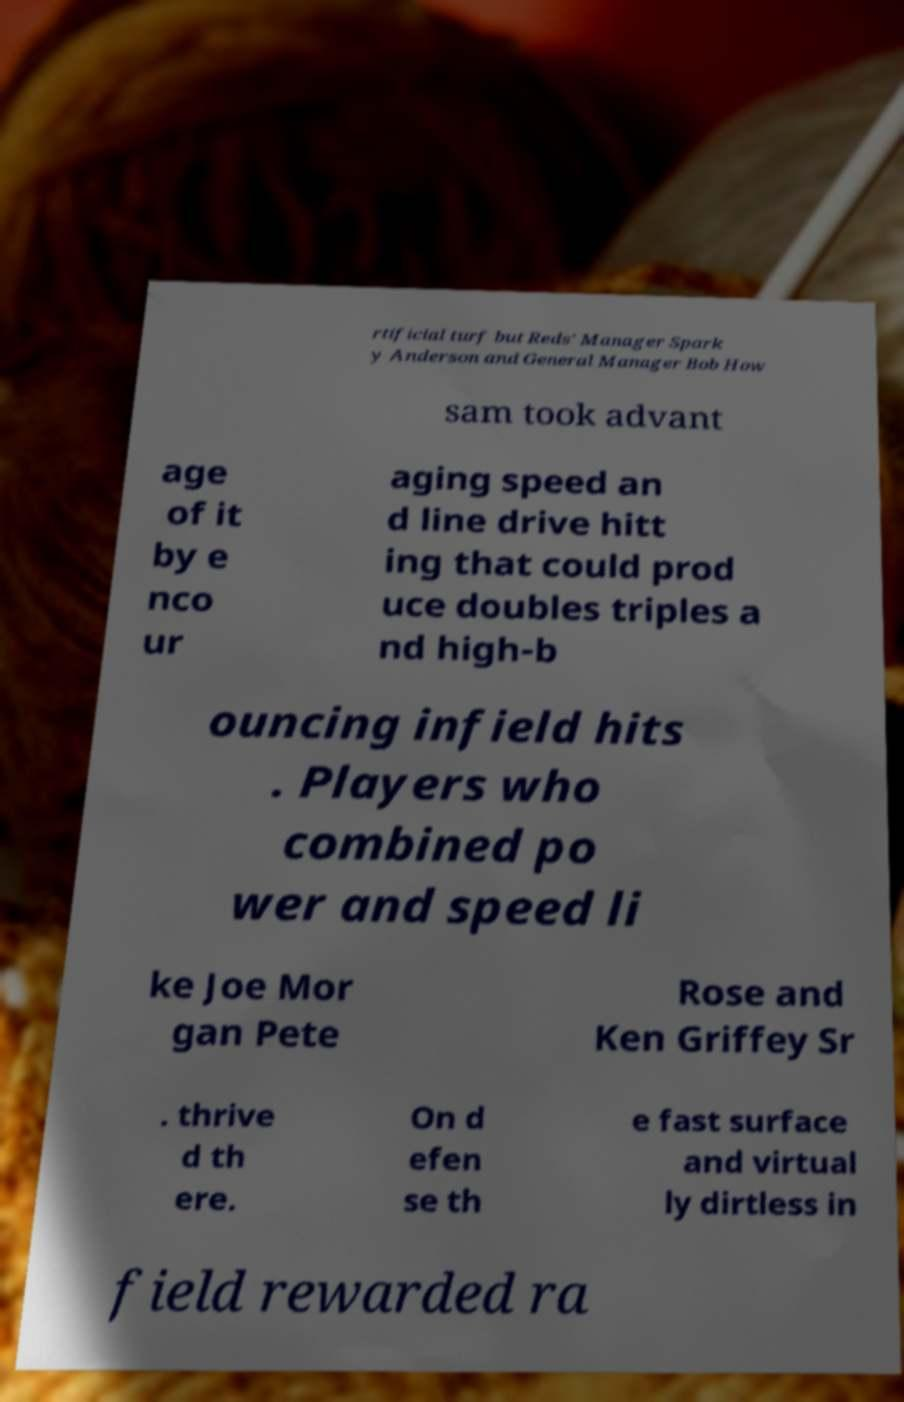Please read and relay the text visible in this image. What does it say? rtificial turf but Reds' Manager Spark y Anderson and General Manager Bob How sam took advant age of it by e nco ur aging speed an d line drive hitt ing that could prod uce doubles triples a nd high-b ouncing infield hits . Players who combined po wer and speed li ke Joe Mor gan Pete Rose and Ken Griffey Sr . thrive d th ere. On d efen se th e fast surface and virtual ly dirtless in field rewarded ra 